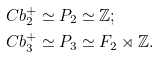<formula> <loc_0><loc_0><loc_500><loc_500>& C b _ { 2 } ^ { + } \simeq P _ { 2 } \simeq \mathbb { Z } ; \\ & C b _ { 3 } ^ { + } \simeq P _ { 3 } \simeq F _ { 2 } \rtimes \mathbb { Z } .</formula> 